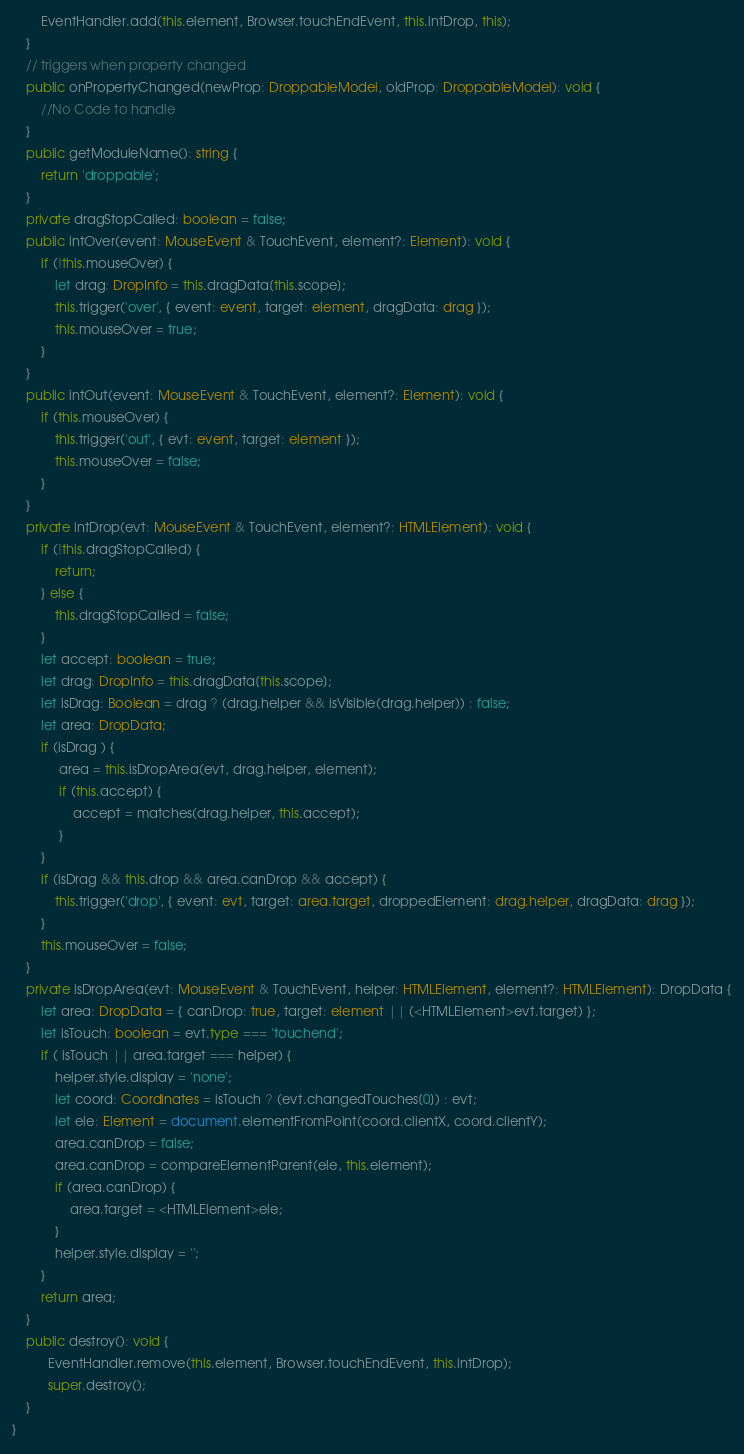Convert code to text. <code><loc_0><loc_0><loc_500><loc_500><_TypeScript_>        EventHandler.add(this.element, Browser.touchEndEvent, this.intDrop, this);
    }
    // triggers when property changed
    public onPropertyChanged(newProp: DroppableModel, oldProp: DroppableModel): void {
        //No Code to handle
    }
    public getModuleName(): string {
        return 'droppable';
    }
    private dragStopCalled: boolean = false;
    public intOver(event: MouseEvent & TouchEvent, element?: Element): void {
        if (!this.mouseOver) {
            let drag: DropInfo = this.dragData[this.scope];
            this.trigger('over', { event: event, target: element, dragData: drag });
            this.mouseOver = true;
        }
    }
    public intOut(event: MouseEvent & TouchEvent, element?: Element): void {
        if (this.mouseOver) {
            this.trigger('out', { evt: event, target: element });
            this.mouseOver = false;
        }
    }
    private intDrop(evt: MouseEvent & TouchEvent, element?: HTMLElement): void {
        if (!this.dragStopCalled) {
            return;
        } else {
            this.dragStopCalled = false;
        }
        let accept: boolean = true;
        let drag: DropInfo = this.dragData[this.scope];
        let isDrag: Boolean = drag ? (drag.helper && isVisible(drag.helper)) : false;
        let area: DropData;
        if (isDrag ) {
             area = this.isDropArea(evt, drag.helper, element);
             if (this.accept) {
                 accept = matches(drag.helper, this.accept);
             }
        }
        if (isDrag && this.drop && area.canDrop && accept) {
            this.trigger('drop', { event: evt, target: area.target, droppedElement: drag.helper, dragData: drag });
        }
        this.mouseOver = false;
    }
    private isDropArea(evt: MouseEvent & TouchEvent, helper: HTMLElement, element?: HTMLElement): DropData {
        let area: DropData = { canDrop: true, target: element || (<HTMLElement>evt.target) };
        let isTouch: boolean = evt.type === 'touchend';
        if ( isTouch || area.target === helper) {
            helper.style.display = 'none';
            let coord: Coordinates = isTouch ? (evt.changedTouches[0]) : evt;
            let ele: Element = document.elementFromPoint(coord.clientX, coord.clientY);
            area.canDrop = false;
            area.canDrop = compareElementParent(ele, this.element);
            if (area.canDrop) {
                area.target = <HTMLElement>ele;
            }
            helper.style.display = '';
        }
        return area;
    }
    public destroy(): void {
          EventHandler.remove(this.element, Browser.touchEndEvent, this.intDrop);
          super.destroy();
    }
}</code> 